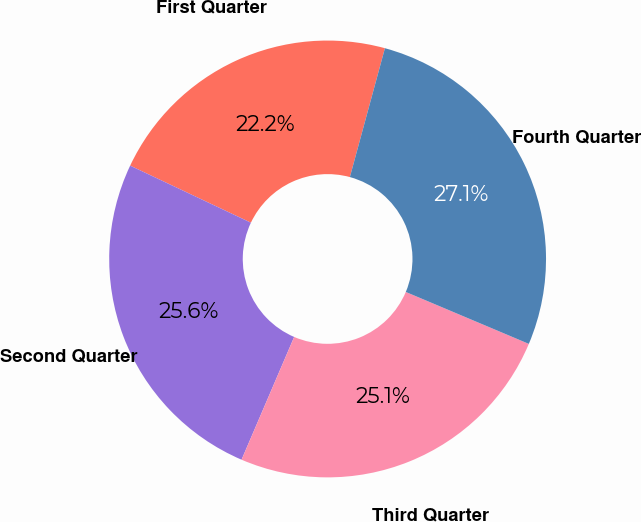Convert chart. <chart><loc_0><loc_0><loc_500><loc_500><pie_chart><fcel>First Quarter<fcel>Second Quarter<fcel>Third Quarter<fcel>Fourth Quarter<nl><fcel>22.2%<fcel>25.58%<fcel>25.09%<fcel>27.13%<nl></chart> 